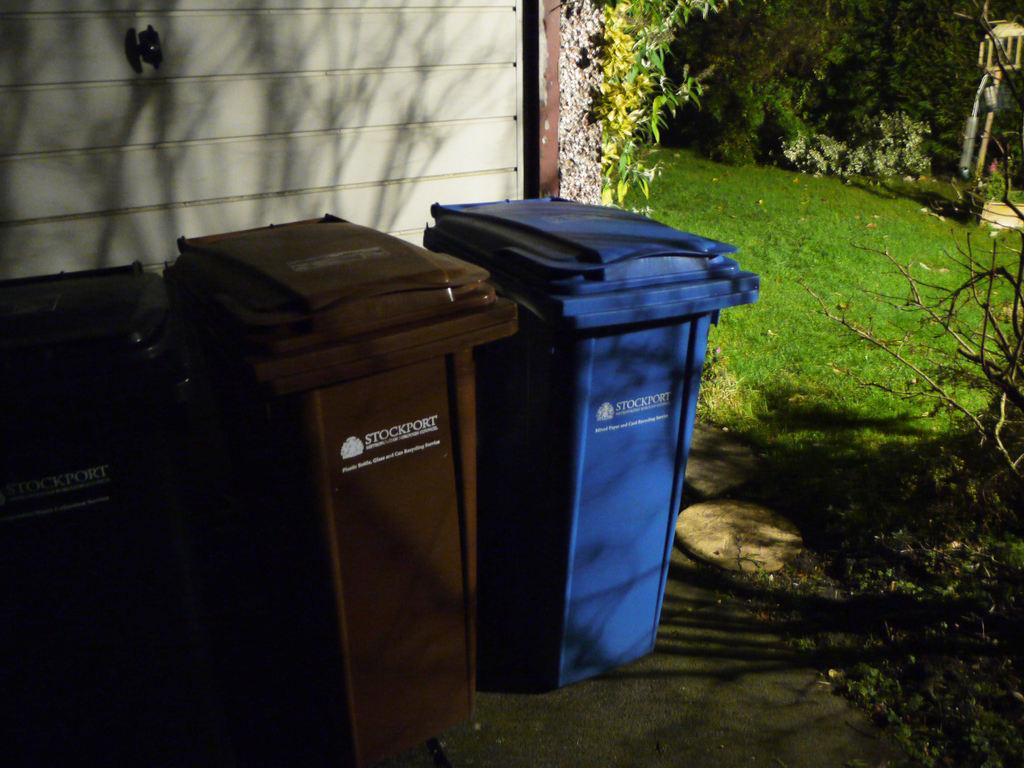Provide a one-sentence caption for the provided image. Three Stockport bins, two brown and one blue, are sitting by the outside wall of a building. 